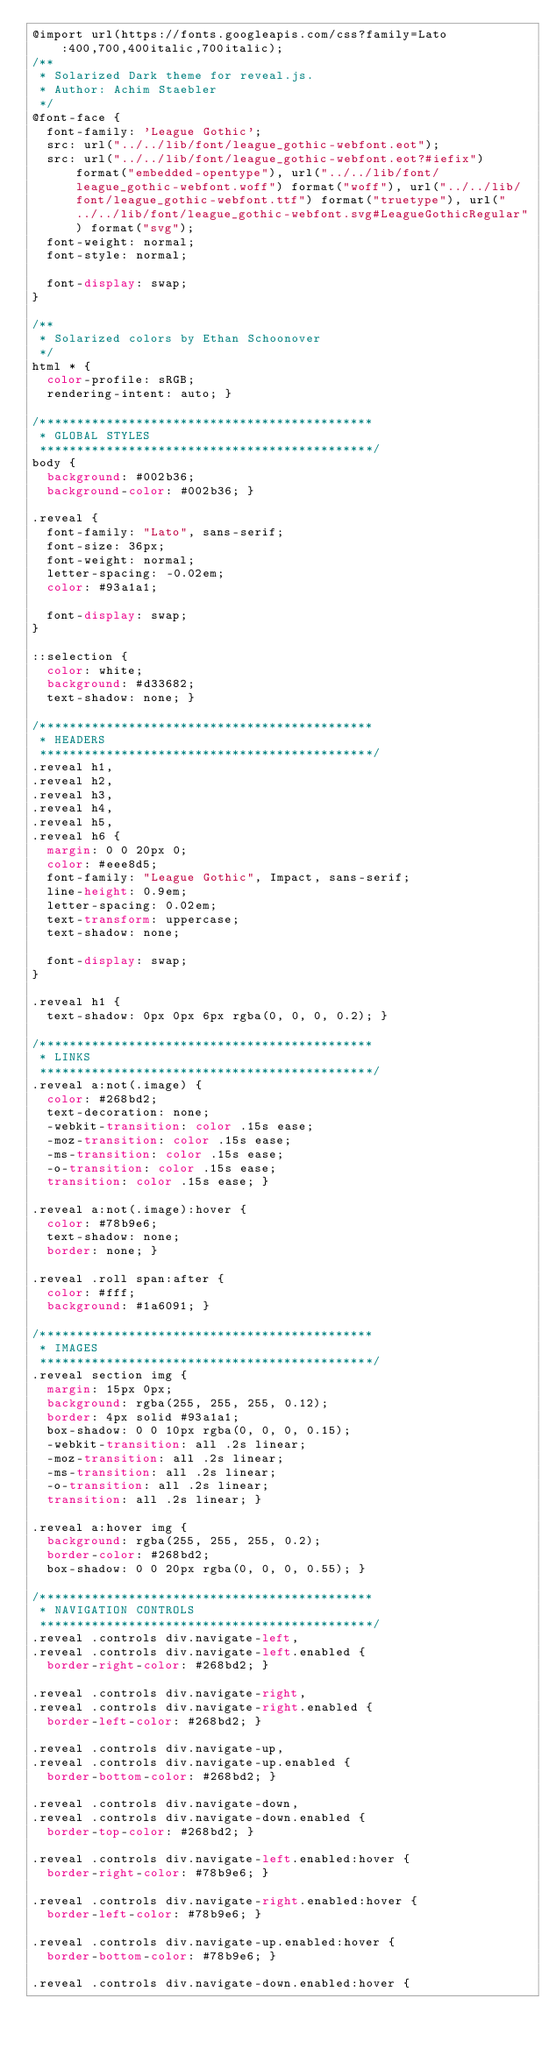Convert code to text. <code><loc_0><loc_0><loc_500><loc_500><_CSS_>@import url(https://fonts.googleapis.com/css?family=Lato:400,700,400italic,700italic);
/**
 * Solarized Dark theme for reveal.js.
 * Author: Achim Staebler
 */
@font-face {
  font-family: 'League Gothic';
  src: url("../../lib/font/league_gothic-webfont.eot");
  src: url("../../lib/font/league_gothic-webfont.eot?#iefix") format("embedded-opentype"), url("../../lib/font/league_gothic-webfont.woff") format("woff"), url("../../lib/font/league_gothic-webfont.ttf") format("truetype"), url("../../lib/font/league_gothic-webfont.svg#LeagueGothicRegular") format("svg");
  font-weight: normal;
  font-style: normal; 

  font-display: swap;
}

/**
 * Solarized colors by Ethan Schoonover
 */
html * {
  color-profile: sRGB;
  rendering-intent: auto; }

/*********************************************
 * GLOBAL STYLES
 *********************************************/
body {
  background: #002b36;
  background-color: #002b36; }

.reveal {
  font-family: "Lato", sans-serif;
  font-size: 36px;
  font-weight: normal;
  letter-spacing: -0.02em;
  color: #93a1a1; 

  font-display: swap;
}

::selection {
  color: white;
  background: #d33682;
  text-shadow: none; }

/*********************************************
 * HEADERS
 *********************************************/
.reveal h1,
.reveal h2,
.reveal h3,
.reveal h4,
.reveal h5,
.reveal h6 {
  margin: 0 0 20px 0;
  color: #eee8d5;
  font-family: "League Gothic", Impact, sans-serif;
  line-height: 0.9em;
  letter-spacing: 0.02em;
  text-transform: uppercase;
  text-shadow: none; 

  font-display: swap;
}

.reveal h1 {
  text-shadow: 0px 0px 6px rgba(0, 0, 0, 0.2); }

/*********************************************
 * LINKS
 *********************************************/
.reveal a:not(.image) {
  color: #268bd2;
  text-decoration: none;
  -webkit-transition: color .15s ease;
  -moz-transition: color .15s ease;
  -ms-transition: color .15s ease;
  -o-transition: color .15s ease;
  transition: color .15s ease; }

.reveal a:not(.image):hover {
  color: #78b9e6;
  text-shadow: none;
  border: none; }

.reveal .roll span:after {
  color: #fff;
  background: #1a6091; }

/*********************************************
 * IMAGES
 *********************************************/
.reveal section img {
  margin: 15px 0px;
  background: rgba(255, 255, 255, 0.12);
  border: 4px solid #93a1a1;
  box-shadow: 0 0 10px rgba(0, 0, 0, 0.15);
  -webkit-transition: all .2s linear;
  -moz-transition: all .2s linear;
  -ms-transition: all .2s linear;
  -o-transition: all .2s linear;
  transition: all .2s linear; }

.reveal a:hover img {
  background: rgba(255, 255, 255, 0.2);
  border-color: #268bd2;
  box-shadow: 0 0 20px rgba(0, 0, 0, 0.55); }

/*********************************************
 * NAVIGATION CONTROLS
 *********************************************/
.reveal .controls div.navigate-left,
.reveal .controls div.navigate-left.enabled {
  border-right-color: #268bd2; }

.reveal .controls div.navigate-right,
.reveal .controls div.navigate-right.enabled {
  border-left-color: #268bd2; }

.reveal .controls div.navigate-up,
.reveal .controls div.navigate-up.enabled {
  border-bottom-color: #268bd2; }

.reveal .controls div.navigate-down,
.reveal .controls div.navigate-down.enabled {
  border-top-color: #268bd2; }

.reveal .controls div.navigate-left.enabled:hover {
  border-right-color: #78b9e6; }

.reveal .controls div.navigate-right.enabled:hover {
  border-left-color: #78b9e6; }

.reveal .controls div.navigate-up.enabled:hover {
  border-bottom-color: #78b9e6; }

.reveal .controls div.navigate-down.enabled:hover {</code> 